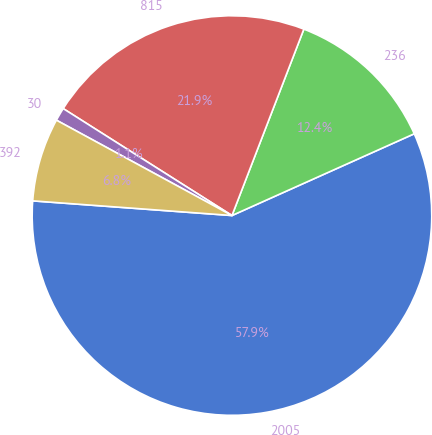Convert chart to OTSL. <chart><loc_0><loc_0><loc_500><loc_500><pie_chart><fcel>2005<fcel>236<fcel>815<fcel>30<fcel>392<nl><fcel>57.88%<fcel>12.43%<fcel>21.87%<fcel>1.07%<fcel>6.75%<nl></chart> 